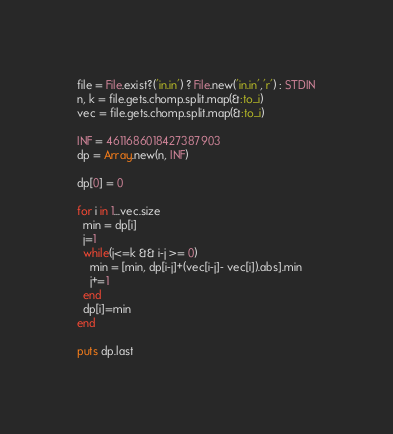<code> <loc_0><loc_0><loc_500><loc_500><_Ruby_>file = File.exist?('in.in') ? File.new('in.in','r') : STDIN
n, k = file.gets.chomp.split.map(&:to_i)
vec = file.gets.chomp.split.map(&:to_i)

INF = 4611686018427387903
dp = Array.new(n, INF)

dp[0] = 0

for i in 1...vec.size
  min = dp[i]
  j=1
  while(j<=k && i-j >= 0)
    min = [min, dp[i-j]+(vec[i-j]- vec[i]).abs].min
    j+=1
  end
  dp[i]=min
end

puts dp.last
</code> 